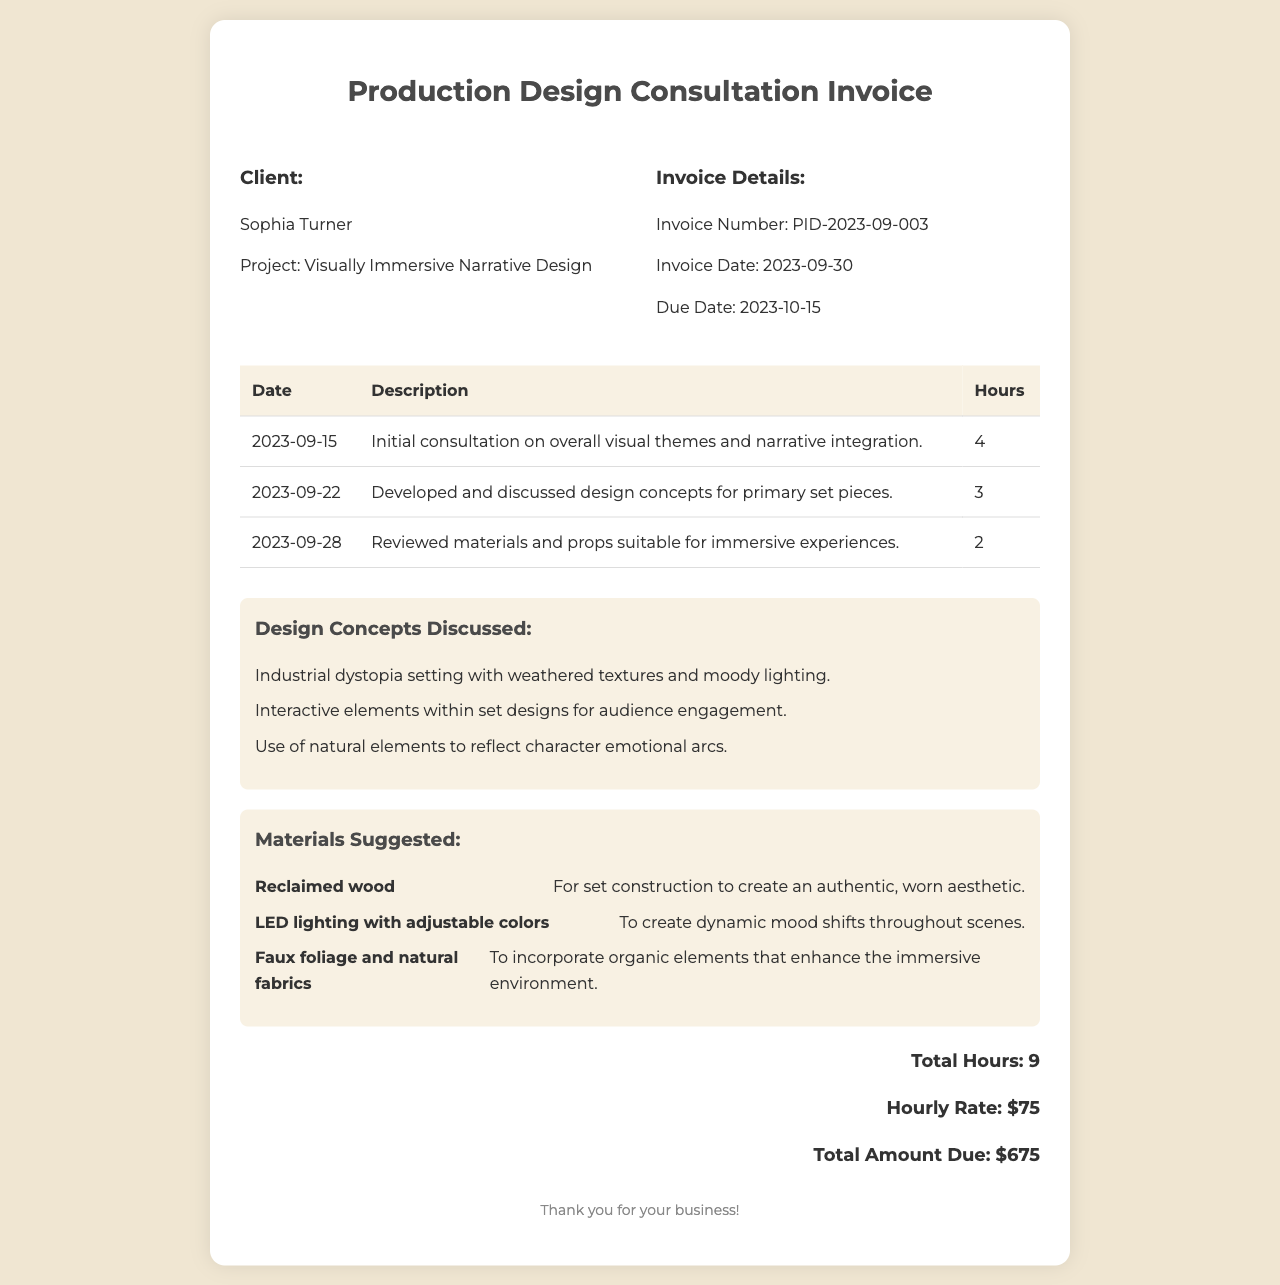What is the client’s name? The client's name is listed prominently in the invoice.
Answer: Sophia Turner What is the project title? The project title is mentioned alongside the client's information.
Answer: Visually Immersive Narrative Design What is the total amount due? The total amount due is calculated and presented clearly in the invoice.
Answer: $675 How many hours were worked in total? The total hours worked are provided at the bottom of the invoice.
Answer: 9 What was discussed in the initial consultation? The description for the initial consultation details the topics of discussion.
Answer: Overall visual themes and narrative integration When was the invoice created? The invoice date is specified in the invoice details section.
Answer: 2023-09-30 What type of materials were suggested for the project? The materials suggested are listed in a dedicated section in the invoice.
Answer: Reclaimed wood, LED lighting, faux foliage Which design concept reflects character emotional arcs? One of the design concepts explicitly mentions character emotional arcs.
Answer: Use of natural elements How much is the hourly rate for the consultation? The hourly rate is stated as part of the total amount calculation.
Answer: $75 